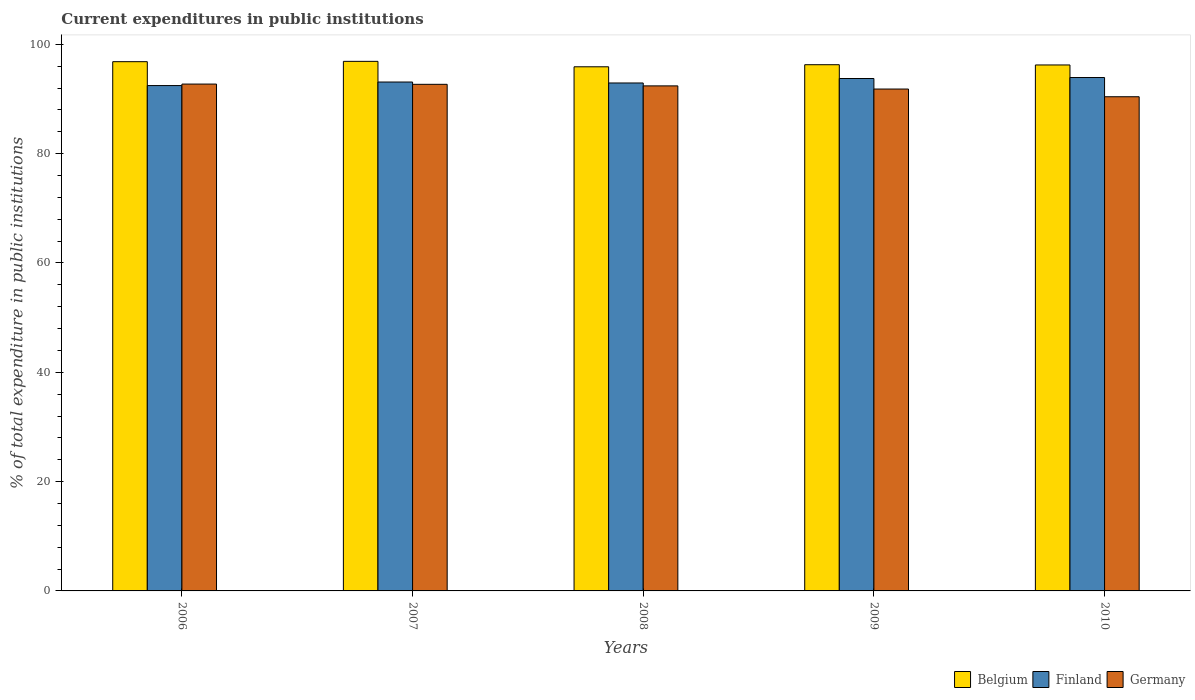How many different coloured bars are there?
Your answer should be compact. 3. How many groups of bars are there?
Offer a terse response. 5. How many bars are there on the 3rd tick from the left?
Ensure brevity in your answer.  3. In how many cases, is the number of bars for a given year not equal to the number of legend labels?
Ensure brevity in your answer.  0. What is the current expenditures in public institutions in Finland in 2009?
Ensure brevity in your answer.  93.74. Across all years, what is the maximum current expenditures in public institutions in Finland?
Offer a very short reply. 93.92. Across all years, what is the minimum current expenditures in public institutions in Germany?
Give a very brief answer. 90.41. In which year was the current expenditures in public institutions in Germany maximum?
Keep it short and to the point. 2006. What is the total current expenditures in public institutions in Belgium in the graph?
Provide a succinct answer. 482.08. What is the difference between the current expenditures in public institutions in Finland in 2006 and that in 2010?
Ensure brevity in your answer.  -1.47. What is the difference between the current expenditures in public institutions in Belgium in 2009 and the current expenditures in public institutions in Finland in 2006?
Your answer should be very brief. 3.81. What is the average current expenditures in public institutions in Belgium per year?
Make the answer very short. 96.42. In the year 2009, what is the difference between the current expenditures in public institutions in Finland and current expenditures in public institutions in Belgium?
Keep it short and to the point. -2.52. In how many years, is the current expenditures in public institutions in Germany greater than 84 %?
Your answer should be very brief. 5. What is the ratio of the current expenditures in public institutions in Belgium in 2006 to that in 2007?
Your response must be concise. 1. What is the difference between the highest and the second highest current expenditures in public institutions in Belgium?
Your response must be concise. 0.06. What is the difference between the highest and the lowest current expenditures in public institutions in Finland?
Provide a short and direct response. 1.47. In how many years, is the current expenditures in public institutions in Belgium greater than the average current expenditures in public institutions in Belgium taken over all years?
Your response must be concise. 2. What does the 1st bar from the left in 2008 represents?
Offer a terse response. Belgium. What does the 2nd bar from the right in 2010 represents?
Your answer should be compact. Finland. Is it the case that in every year, the sum of the current expenditures in public institutions in Germany and current expenditures in public institutions in Belgium is greater than the current expenditures in public institutions in Finland?
Your answer should be very brief. Yes. How many years are there in the graph?
Ensure brevity in your answer.  5. Are the values on the major ticks of Y-axis written in scientific E-notation?
Provide a short and direct response. No. Does the graph contain any zero values?
Offer a terse response. No. Where does the legend appear in the graph?
Keep it short and to the point. Bottom right. What is the title of the graph?
Provide a short and direct response. Current expenditures in public institutions. What is the label or title of the X-axis?
Your answer should be very brief. Years. What is the label or title of the Y-axis?
Offer a terse response. % of total expenditure in public institutions. What is the % of total expenditure in public institutions of Belgium in 2006?
Make the answer very short. 96.82. What is the % of total expenditure in public institutions of Finland in 2006?
Make the answer very short. 92.45. What is the % of total expenditure in public institutions of Germany in 2006?
Provide a succinct answer. 92.73. What is the % of total expenditure in public institutions of Belgium in 2007?
Keep it short and to the point. 96.88. What is the % of total expenditure in public institutions in Finland in 2007?
Keep it short and to the point. 93.1. What is the % of total expenditure in public institutions of Germany in 2007?
Give a very brief answer. 92.68. What is the % of total expenditure in public institutions in Belgium in 2008?
Provide a succinct answer. 95.89. What is the % of total expenditure in public institutions of Finland in 2008?
Provide a succinct answer. 92.93. What is the % of total expenditure in public institutions of Germany in 2008?
Offer a very short reply. 92.39. What is the % of total expenditure in public institutions in Belgium in 2009?
Make the answer very short. 96.27. What is the % of total expenditure in public institutions of Finland in 2009?
Your response must be concise. 93.74. What is the % of total expenditure in public institutions in Germany in 2009?
Ensure brevity in your answer.  91.82. What is the % of total expenditure in public institutions in Belgium in 2010?
Your response must be concise. 96.22. What is the % of total expenditure in public institutions of Finland in 2010?
Your response must be concise. 93.92. What is the % of total expenditure in public institutions of Germany in 2010?
Offer a very short reply. 90.41. Across all years, what is the maximum % of total expenditure in public institutions in Belgium?
Your answer should be compact. 96.88. Across all years, what is the maximum % of total expenditure in public institutions in Finland?
Your response must be concise. 93.92. Across all years, what is the maximum % of total expenditure in public institutions in Germany?
Your response must be concise. 92.73. Across all years, what is the minimum % of total expenditure in public institutions in Belgium?
Offer a very short reply. 95.89. Across all years, what is the minimum % of total expenditure in public institutions of Finland?
Make the answer very short. 92.45. Across all years, what is the minimum % of total expenditure in public institutions of Germany?
Offer a terse response. 90.41. What is the total % of total expenditure in public institutions of Belgium in the graph?
Make the answer very short. 482.08. What is the total % of total expenditure in public institutions of Finland in the graph?
Make the answer very short. 466.15. What is the total % of total expenditure in public institutions in Germany in the graph?
Give a very brief answer. 460.03. What is the difference between the % of total expenditure in public institutions in Belgium in 2006 and that in 2007?
Give a very brief answer. -0.06. What is the difference between the % of total expenditure in public institutions of Finland in 2006 and that in 2007?
Give a very brief answer. -0.65. What is the difference between the % of total expenditure in public institutions in Germany in 2006 and that in 2007?
Offer a very short reply. 0.05. What is the difference between the % of total expenditure in public institutions of Belgium in 2006 and that in 2008?
Provide a short and direct response. 0.93. What is the difference between the % of total expenditure in public institutions of Finland in 2006 and that in 2008?
Ensure brevity in your answer.  -0.47. What is the difference between the % of total expenditure in public institutions in Germany in 2006 and that in 2008?
Give a very brief answer. 0.33. What is the difference between the % of total expenditure in public institutions of Belgium in 2006 and that in 2009?
Your answer should be very brief. 0.55. What is the difference between the % of total expenditure in public institutions of Finland in 2006 and that in 2009?
Your response must be concise. -1.29. What is the difference between the % of total expenditure in public institutions in Germany in 2006 and that in 2009?
Offer a terse response. 0.91. What is the difference between the % of total expenditure in public institutions of Belgium in 2006 and that in 2010?
Offer a very short reply. 0.6. What is the difference between the % of total expenditure in public institutions in Finland in 2006 and that in 2010?
Make the answer very short. -1.47. What is the difference between the % of total expenditure in public institutions of Germany in 2006 and that in 2010?
Offer a very short reply. 2.32. What is the difference between the % of total expenditure in public institutions of Finland in 2007 and that in 2008?
Offer a terse response. 0.17. What is the difference between the % of total expenditure in public institutions of Germany in 2007 and that in 2008?
Provide a succinct answer. 0.29. What is the difference between the % of total expenditure in public institutions in Belgium in 2007 and that in 2009?
Offer a very short reply. 0.61. What is the difference between the % of total expenditure in public institutions of Finland in 2007 and that in 2009?
Your answer should be very brief. -0.64. What is the difference between the % of total expenditure in public institutions in Germany in 2007 and that in 2009?
Provide a short and direct response. 0.86. What is the difference between the % of total expenditure in public institutions in Belgium in 2007 and that in 2010?
Your answer should be very brief. 0.66. What is the difference between the % of total expenditure in public institutions in Finland in 2007 and that in 2010?
Your answer should be compact. -0.82. What is the difference between the % of total expenditure in public institutions in Germany in 2007 and that in 2010?
Your answer should be very brief. 2.27. What is the difference between the % of total expenditure in public institutions in Belgium in 2008 and that in 2009?
Offer a terse response. -0.38. What is the difference between the % of total expenditure in public institutions of Finland in 2008 and that in 2009?
Your response must be concise. -0.82. What is the difference between the % of total expenditure in public institutions of Germany in 2008 and that in 2009?
Offer a terse response. 0.58. What is the difference between the % of total expenditure in public institutions of Belgium in 2008 and that in 2010?
Ensure brevity in your answer.  -0.33. What is the difference between the % of total expenditure in public institutions of Finland in 2008 and that in 2010?
Your answer should be compact. -1. What is the difference between the % of total expenditure in public institutions in Germany in 2008 and that in 2010?
Your answer should be compact. 1.98. What is the difference between the % of total expenditure in public institutions in Belgium in 2009 and that in 2010?
Your answer should be very brief. 0.04. What is the difference between the % of total expenditure in public institutions of Finland in 2009 and that in 2010?
Ensure brevity in your answer.  -0.18. What is the difference between the % of total expenditure in public institutions of Germany in 2009 and that in 2010?
Keep it short and to the point. 1.41. What is the difference between the % of total expenditure in public institutions of Belgium in 2006 and the % of total expenditure in public institutions of Finland in 2007?
Your answer should be compact. 3.72. What is the difference between the % of total expenditure in public institutions in Belgium in 2006 and the % of total expenditure in public institutions in Germany in 2007?
Keep it short and to the point. 4.14. What is the difference between the % of total expenditure in public institutions in Finland in 2006 and the % of total expenditure in public institutions in Germany in 2007?
Make the answer very short. -0.23. What is the difference between the % of total expenditure in public institutions in Belgium in 2006 and the % of total expenditure in public institutions in Finland in 2008?
Your response must be concise. 3.89. What is the difference between the % of total expenditure in public institutions in Belgium in 2006 and the % of total expenditure in public institutions in Germany in 2008?
Offer a very short reply. 4.43. What is the difference between the % of total expenditure in public institutions of Finland in 2006 and the % of total expenditure in public institutions of Germany in 2008?
Provide a succinct answer. 0.06. What is the difference between the % of total expenditure in public institutions of Belgium in 2006 and the % of total expenditure in public institutions of Finland in 2009?
Give a very brief answer. 3.08. What is the difference between the % of total expenditure in public institutions in Belgium in 2006 and the % of total expenditure in public institutions in Germany in 2009?
Keep it short and to the point. 5. What is the difference between the % of total expenditure in public institutions in Finland in 2006 and the % of total expenditure in public institutions in Germany in 2009?
Offer a terse response. 0.64. What is the difference between the % of total expenditure in public institutions in Belgium in 2006 and the % of total expenditure in public institutions in Finland in 2010?
Make the answer very short. 2.9. What is the difference between the % of total expenditure in public institutions of Belgium in 2006 and the % of total expenditure in public institutions of Germany in 2010?
Provide a succinct answer. 6.41. What is the difference between the % of total expenditure in public institutions in Finland in 2006 and the % of total expenditure in public institutions in Germany in 2010?
Provide a short and direct response. 2.04. What is the difference between the % of total expenditure in public institutions in Belgium in 2007 and the % of total expenditure in public institutions in Finland in 2008?
Your response must be concise. 3.95. What is the difference between the % of total expenditure in public institutions of Belgium in 2007 and the % of total expenditure in public institutions of Germany in 2008?
Give a very brief answer. 4.49. What is the difference between the % of total expenditure in public institutions in Finland in 2007 and the % of total expenditure in public institutions in Germany in 2008?
Keep it short and to the point. 0.71. What is the difference between the % of total expenditure in public institutions in Belgium in 2007 and the % of total expenditure in public institutions in Finland in 2009?
Offer a terse response. 3.14. What is the difference between the % of total expenditure in public institutions in Belgium in 2007 and the % of total expenditure in public institutions in Germany in 2009?
Provide a short and direct response. 5.06. What is the difference between the % of total expenditure in public institutions in Finland in 2007 and the % of total expenditure in public institutions in Germany in 2009?
Make the answer very short. 1.28. What is the difference between the % of total expenditure in public institutions in Belgium in 2007 and the % of total expenditure in public institutions in Finland in 2010?
Ensure brevity in your answer.  2.96. What is the difference between the % of total expenditure in public institutions in Belgium in 2007 and the % of total expenditure in public institutions in Germany in 2010?
Your answer should be very brief. 6.47. What is the difference between the % of total expenditure in public institutions of Finland in 2007 and the % of total expenditure in public institutions of Germany in 2010?
Make the answer very short. 2.69. What is the difference between the % of total expenditure in public institutions of Belgium in 2008 and the % of total expenditure in public institutions of Finland in 2009?
Offer a very short reply. 2.15. What is the difference between the % of total expenditure in public institutions in Belgium in 2008 and the % of total expenditure in public institutions in Germany in 2009?
Provide a short and direct response. 4.07. What is the difference between the % of total expenditure in public institutions in Finland in 2008 and the % of total expenditure in public institutions in Germany in 2009?
Offer a very short reply. 1.11. What is the difference between the % of total expenditure in public institutions of Belgium in 2008 and the % of total expenditure in public institutions of Finland in 2010?
Your response must be concise. 1.96. What is the difference between the % of total expenditure in public institutions in Belgium in 2008 and the % of total expenditure in public institutions in Germany in 2010?
Keep it short and to the point. 5.48. What is the difference between the % of total expenditure in public institutions of Finland in 2008 and the % of total expenditure in public institutions of Germany in 2010?
Provide a succinct answer. 2.52. What is the difference between the % of total expenditure in public institutions of Belgium in 2009 and the % of total expenditure in public institutions of Finland in 2010?
Your response must be concise. 2.34. What is the difference between the % of total expenditure in public institutions in Belgium in 2009 and the % of total expenditure in public institutions in Germany in 2010?
Your response must be concise. 5.86. What is the difference between the % of total expenditure in public institutions of Finland in 2009 and the % of total expenditure in public institutions of Germany in 2010?
Your response must be concise. 3.33. What is the average % of total expenditure in public institutions of Belgium per year?
Give a very brief answer. 96.42. What is the average % of total expenditure in public institutions of Finland per year?
Offer a very short reply. 93.23. What is the average % of total expenditure in public institutions in Germany per year?
Offer a terse response. 92.01. In the year 2006, what is the difference between the % of total expenditure in public institutions of Belgium and % of total expenditure in public institutions of Finland?
Ensure brevity in your answer.  4.37. In the year 2006, what is the difference between the % of total expenditure in public institutions in Belgium and % of total expenditure in public institutions in Germany?
Your answer should be compact. 4.1. In the year 2006, what is the difference between the % of total expenditure in public institutions in Finland and % of total expenditure in public institutions in Germany?
Offer a very short reply. -0.27. In the year 2007, what is the difference between the % of total expenditure in public institutions in Belgium and % of total expenditure in public institutions in Finland?
Give a very brief answer. 3.78. In the year 2007, what is the difference between the % of total expenditure in public institutions in Belgium and % of total expenditure in public institutions in Germany?
Offer a terse response. 4.2. In the year 2007, what is the difference between the % of total expenditure in public institutions in Finland and % of total expenditure in public institutions in Germany?
Your response must be concise. 0.42. In the year 2008, what is the difference between the % of total expenditure in public institutions in Belgium and % of total expenditure in public institutions in Finland?
Ensure brevity in your answer.  2.96. In the year 2008, what is the difference between the % of total expenditure in public institutions of Belgium and % of total expenditure in public institutions of Germany?
Provide a short and direct response. 3.49. In the year 2008, what is the difference between the % of total expenditure in public institutions in Finland and % of total expenditure in public institutions in Germany?
Provide a succinct answer. 0.53. In the year 2009, what is the difference between the % of total expenditure in public institutions of Belgium and % of total expenditure in public institutions of Finland?
Make the answer very short. 2.52. In the year 2009, what is the difference between the % of total expenditure in public institutions in Belgium and % of total expenditure in public institutions in Germany?
Offer a terse response. 4.45. In the year 2009, what is the difference between the % of total expenditure in public institutions of Finland and % of total expenditure in public institutions of Germany?
Provide a short and direct response. 1.92. In the year 2010, what is the difference between the % of total expenditure in public institutions of Belgium and % of total expenditure in public institutions of Finland?
Provide a short and direct response. 2.3. In the year 2010, what is the difference between the % of total expenditure in public institutions in Belgium and % of total expenditure in public institutions in Germany?
Your answer should be compact. 5.81. In the year 2010, what is the difference between the % of total expenditure in public institutions of Finland and % of total expenditure in public institutions of Germany?
Keep it short and to the point. 3.52. What is the ratio of the % of total expenditure in public institutions of Finland in 2006 to that in 2007?
Give a very brief answer. 0.99. What is the ratio of the % of total expenditure in public institutions of Belgium in 2006 to that in 2008?
Make the answer very short. 1.01. What is the ratio of the % of total expenditure in public institutions of Germany in 2006 to that in 2008?
Offer a very short reply. 1. What is the ratio of the % of total expenditure in public institutions of Finland in 2006 to that in 2009?
Offer a very short reply. 0.99. What is the ratio of the % of total expenditure in public institutions of Germany in 2006 to that in 2009?
Your response must be concise. 1.01. What is the ratio of the % of total expenditure in public institutions of Belgium in 2006 to that in 2010?
Make the answer very short. 1.01. What is the ratio of the % of total expenditure in public institutions in Finland in 2006 to that in 2010?
Your response must be concise. 0.98. What is the ratio of the % of total expenditure in public institutions of Germany in 2006 to that in 2010?
Your answer should be compact. 1.03. What is the ratio of the % of total expenditure in public institutions of Belgium in 2007 to that in 2008?
Offer a very short reply. 1.01. What is the ratio of the % of total expenditure in public institutions of Germany in 2007 to that in 2008?
Keep it short and to the point. 1. What is the ratio of the % of total expenditure in public institutions of Belgium in 2007 to that in 2009?
Offer a terse response. 1.01. What is the ratio of the % of total expenditure in public institutions in Finland in 2007 to that in 2009?
Your response must be concise. 0.99. What is the ratio of the % of total expenditure in public institutions of Germany in 2007 to that in 2009?
Ensure brevity in your answer.  1.01. What is the ratio of the % of total expenditure in public institutions of Finland in 2007 to that in 2010?
Give a very brief answer. 0.99. What is the ratio of the % of total expenditure in public institutions in Germany in 2007 to that in 2010?
Provide a succinct answer. 1.03. What is the ratio of the % of total expenditure in public institutions of Belgium in 2009 to that in 2010?
Give a very brief answer. 1. What is the ratio of the % of total expenditure in public institutions in Germany in 2009 to that in 2010?
Your answer should be very brief. 1.02. What is the difference between the highest and the second highest % of total expenditure in public institutions in Belgium?
Your answer should be very brief. 0.06. What is the difference between the highest and the second highest % of total expenditure in public institutions of Finland?
Your answer should be very brief. 0.18. What is the difference between the highest and the second highest % of total expenditure in public institutions of Germany?
Keep it short and to the point. 0.05. What is the difference between the highest and the lowest % of total expenditure in public institutions of Belgium?
Offer a very short reply. 0.99. What is the difference between the highest and the lowest % of total expenditure in public institutions in Finland?
Give a very brief answer. 1.47. What is the difference between the highest and the lowest % of total expenditure in public institutions of Germany?
Keep it short and to the point. 2.32. 